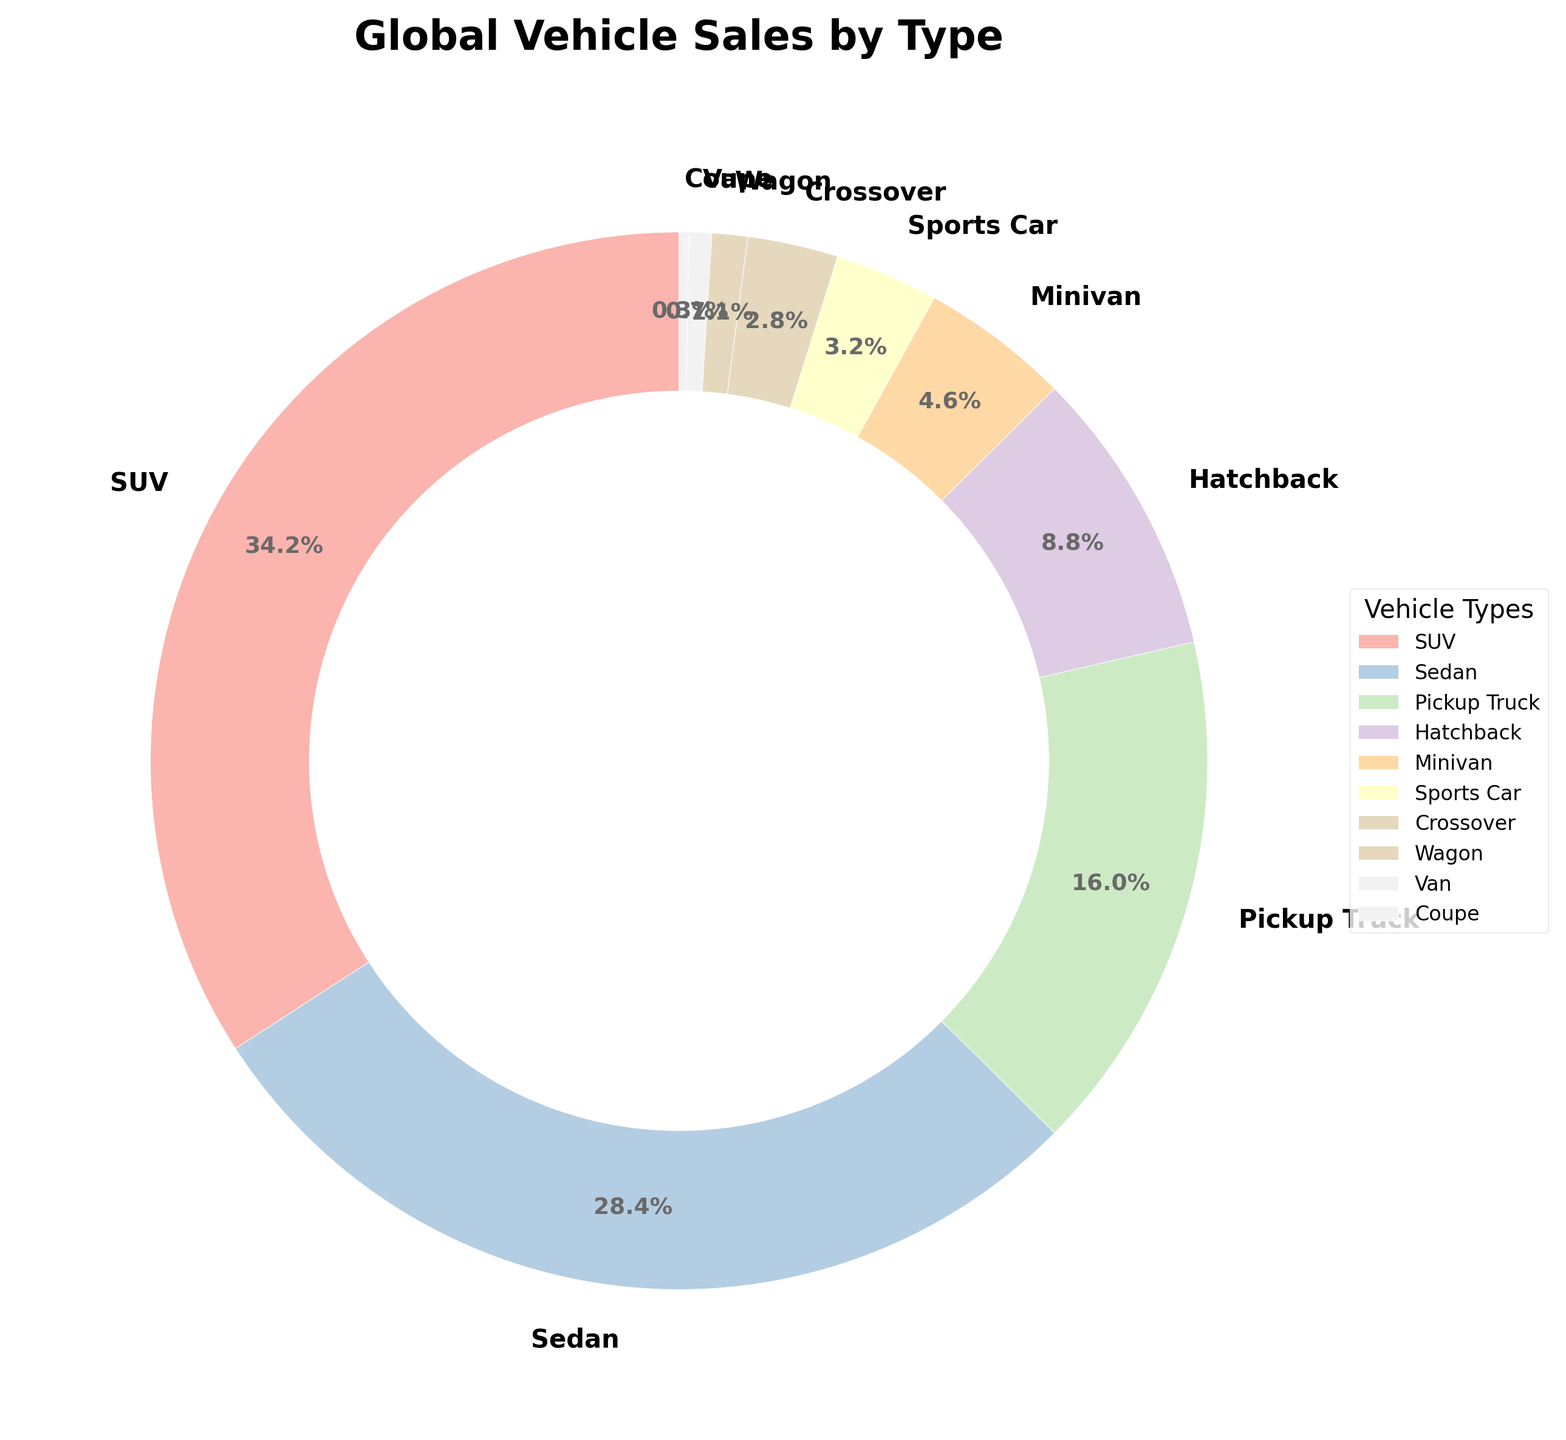What's the most popular vehicle type in global sales? The pie chart shows that SUVs have the largest slice, indicating the highest percentage of global sales.
Answer: SUV Which type of vehicle accounts for less than 1% of global sales? The chart shows that Vans and Coupes have the smallest slices, and their percentages are 0.7% and 0.3%, respectively. Both account for less than 1%.
Answer: Vans and Coupes What percentage of global sales do SUVs and Sedans together account for? Add the percentages of SUVs and Sedans: 34.5% + 28.7% = 63.2%
Answer: 63.2% Which vehicle type has the third highest percentage of global sales? Pickup Trucks have the third largest slice after SUVs and Sedans, with a percentage of 16.2%.
Answer: Pickup Trucks How does the percentage of Hatchbacks compare to Minivans? The chart shows Hatchbacks at 8.9% and Minivans at 4.6%, so Hatchbacks have a higher percentage than Minivans.
Answer: Hatchbacks have a higher percentage What is the combined percentage of Pickup Trucks, Hatchbacks, and Minivans? Add the percentages of Pickup Trucks, Hatchbacks, and Minivans: 16.2% + 8.9% + 4.6% = 29.7%
Answer: 29.7% Order the top three vehicle types from most to least popular in global sales. The top three vehicle types by percentage are SUVs (34.5%), Sedans (28.7%), and Pickup Trucks (16.2%). Therefore, the order is SUV, Sedan, and Pickup Truck.
Answer: SUV, Sedan, Pickup Truck Which vehicle types together make up less than 5% of the global sales each? According to the chart, Sports Cars (3.2%), Crossovers (2.8%), Wagons (1.1%), Vans (0.7%), and Coupes (0.3%) each make up less than 5% of the global sales.
Answer: Sports Cars, Crossovers, Wagons, Vans, Coupes What is the ratio of SUVs to Sedans in terms of global sales percentage? The percentage of SUVs is 34.5% and Sedans is 28.7%. To find the ratio, divide 34.5 by 28.7, which equals approximately 1.20.
Answer: 1.20 What is the difference in global sales percentage between the most popular and least popular vehicle types? The most popular is SUVs at 34.5%, and the least popular is Coupes at 0.3%. Subtract 0.3 from 34.5 to get 34.2%.
Answer: 34.2% 